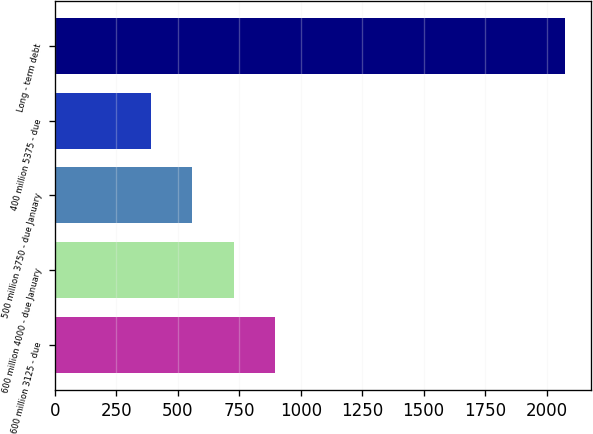Convert chart to OTSL. <chart><loc_0><loc_0><loc_500><loc_500><bar_chart><fcel>600 million 3125 - due<fcel>600 million 4000 - due January<fcel>500 million 3750 - due January<fcel>400 million 5375 - due<fcel>Long - term debt<nl><fcel>895.6<fcel>727<fcel>558.4<fcel>389.8<fcel>2075.8<nl></chart> 